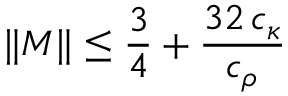Convert formula to latex. <formula><loc_0><loc_0><loc_500><loc_500>\| M \| \leq \frac { 3 } { 4 } + \frac { 3 2 \, c _ { \kappa } } { c _ { \rho } }</formula> 